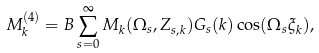<formula> <loc_0><loc_0><loc_500><loc_500>M _ { k } ^ { ( 4 ) } = B \sum _ { s = 0 } ^ { \infty } M _ { k } ( \Omega _ { s } , Z _ { s , k } ) G _ { s } ( k ) \cos ( \Omega _ { s } \xi _ { k } ) ,</formula> 